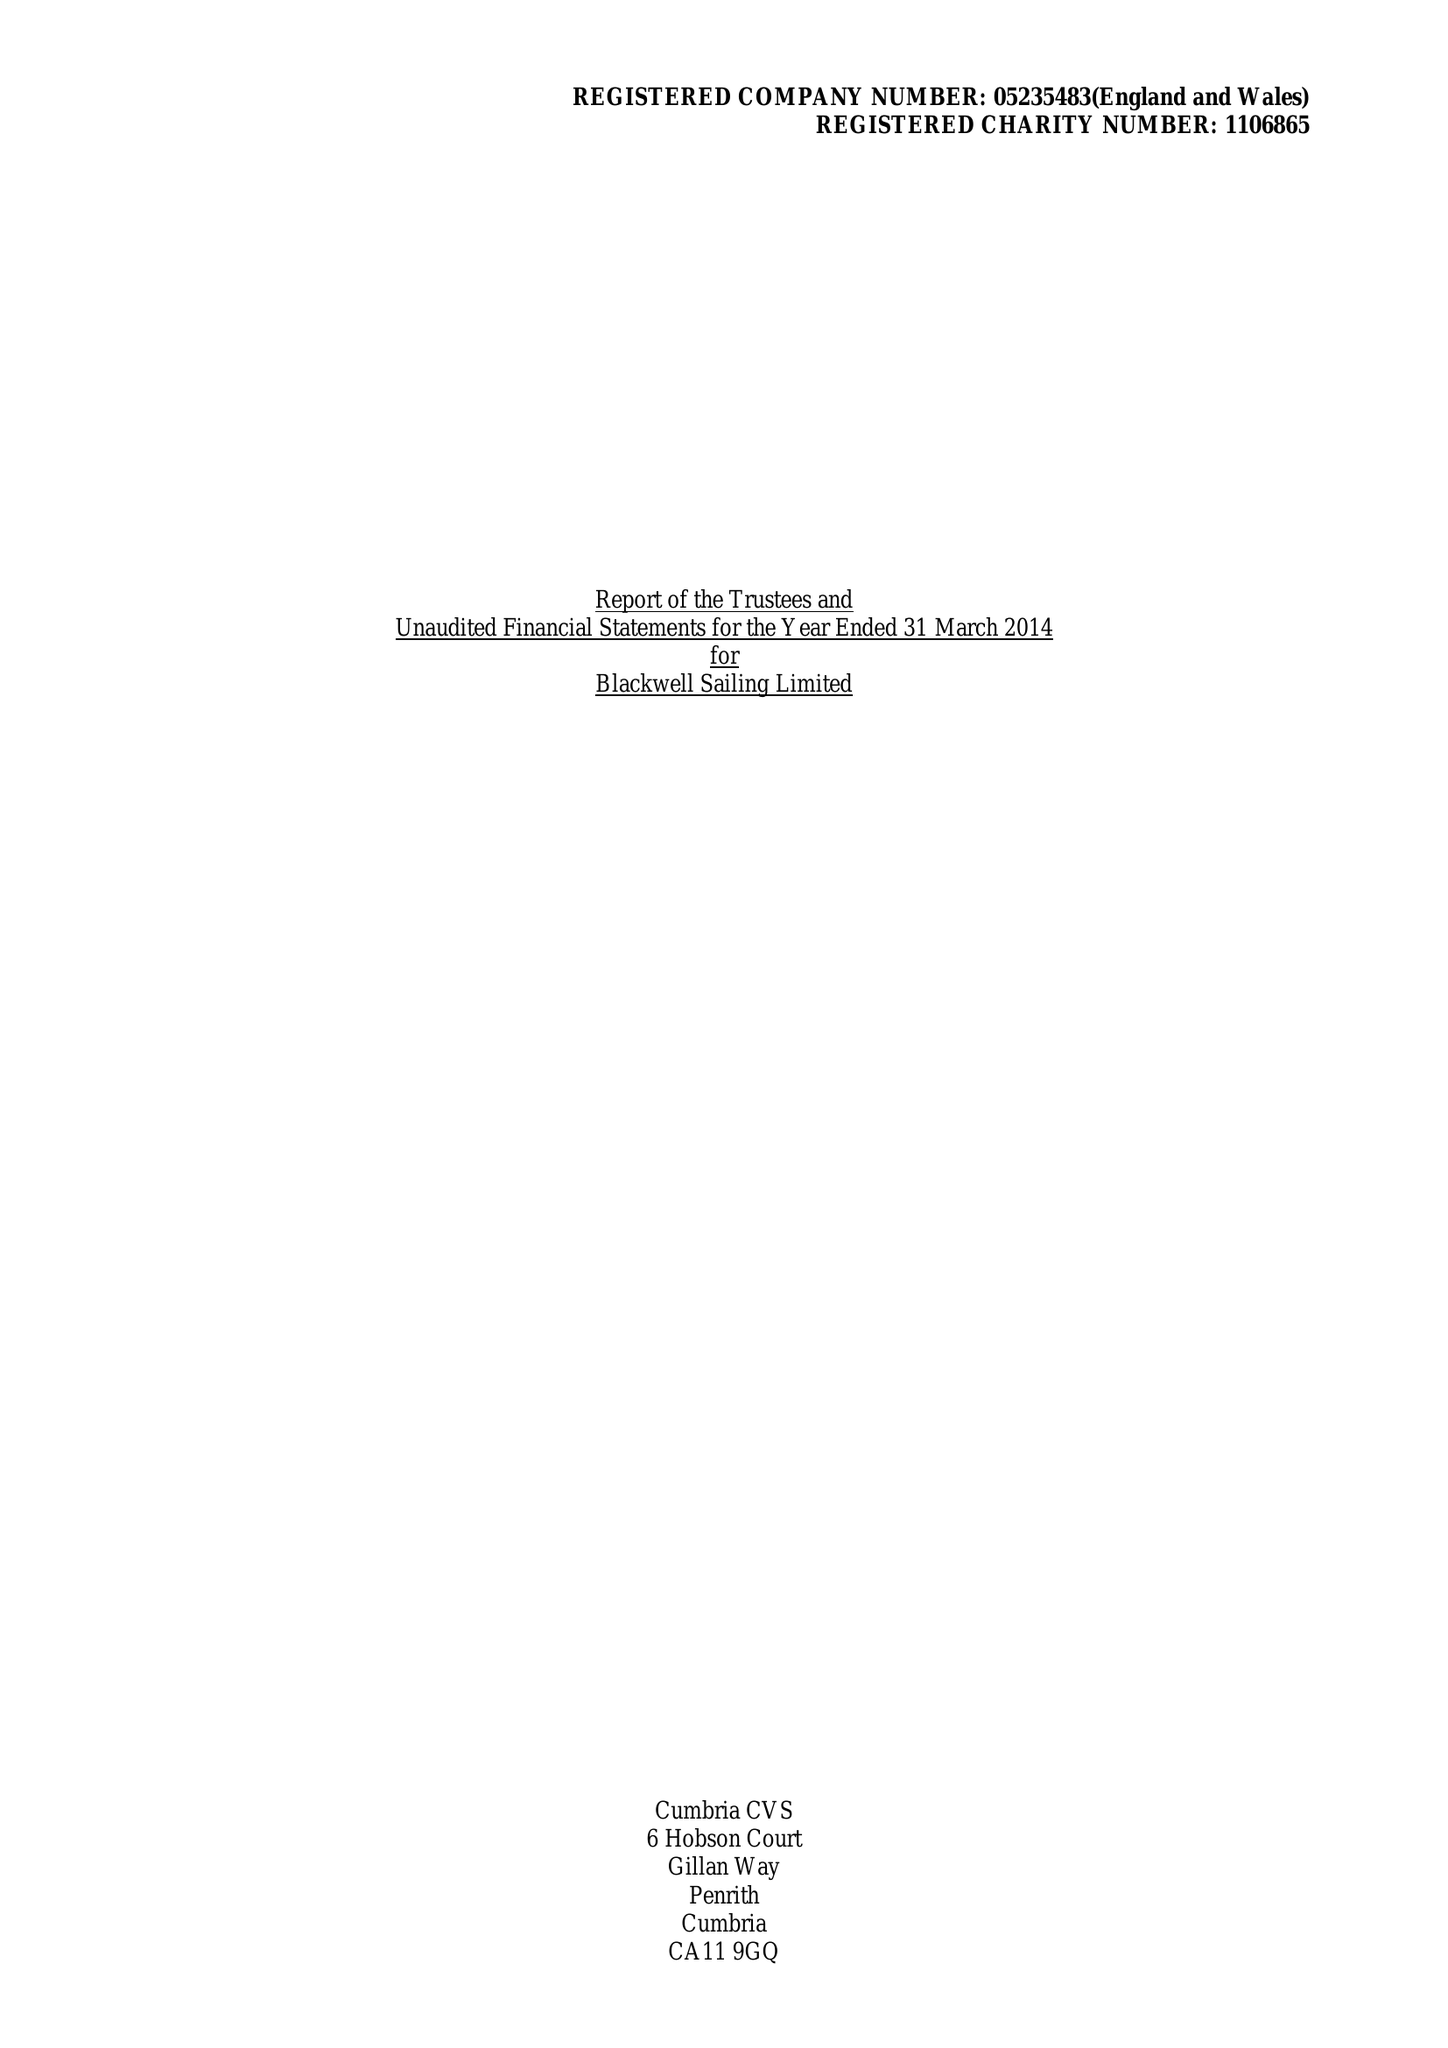What is the value for the address__postcode?
Answer the question using a single word or phrase. LA23 3HE 